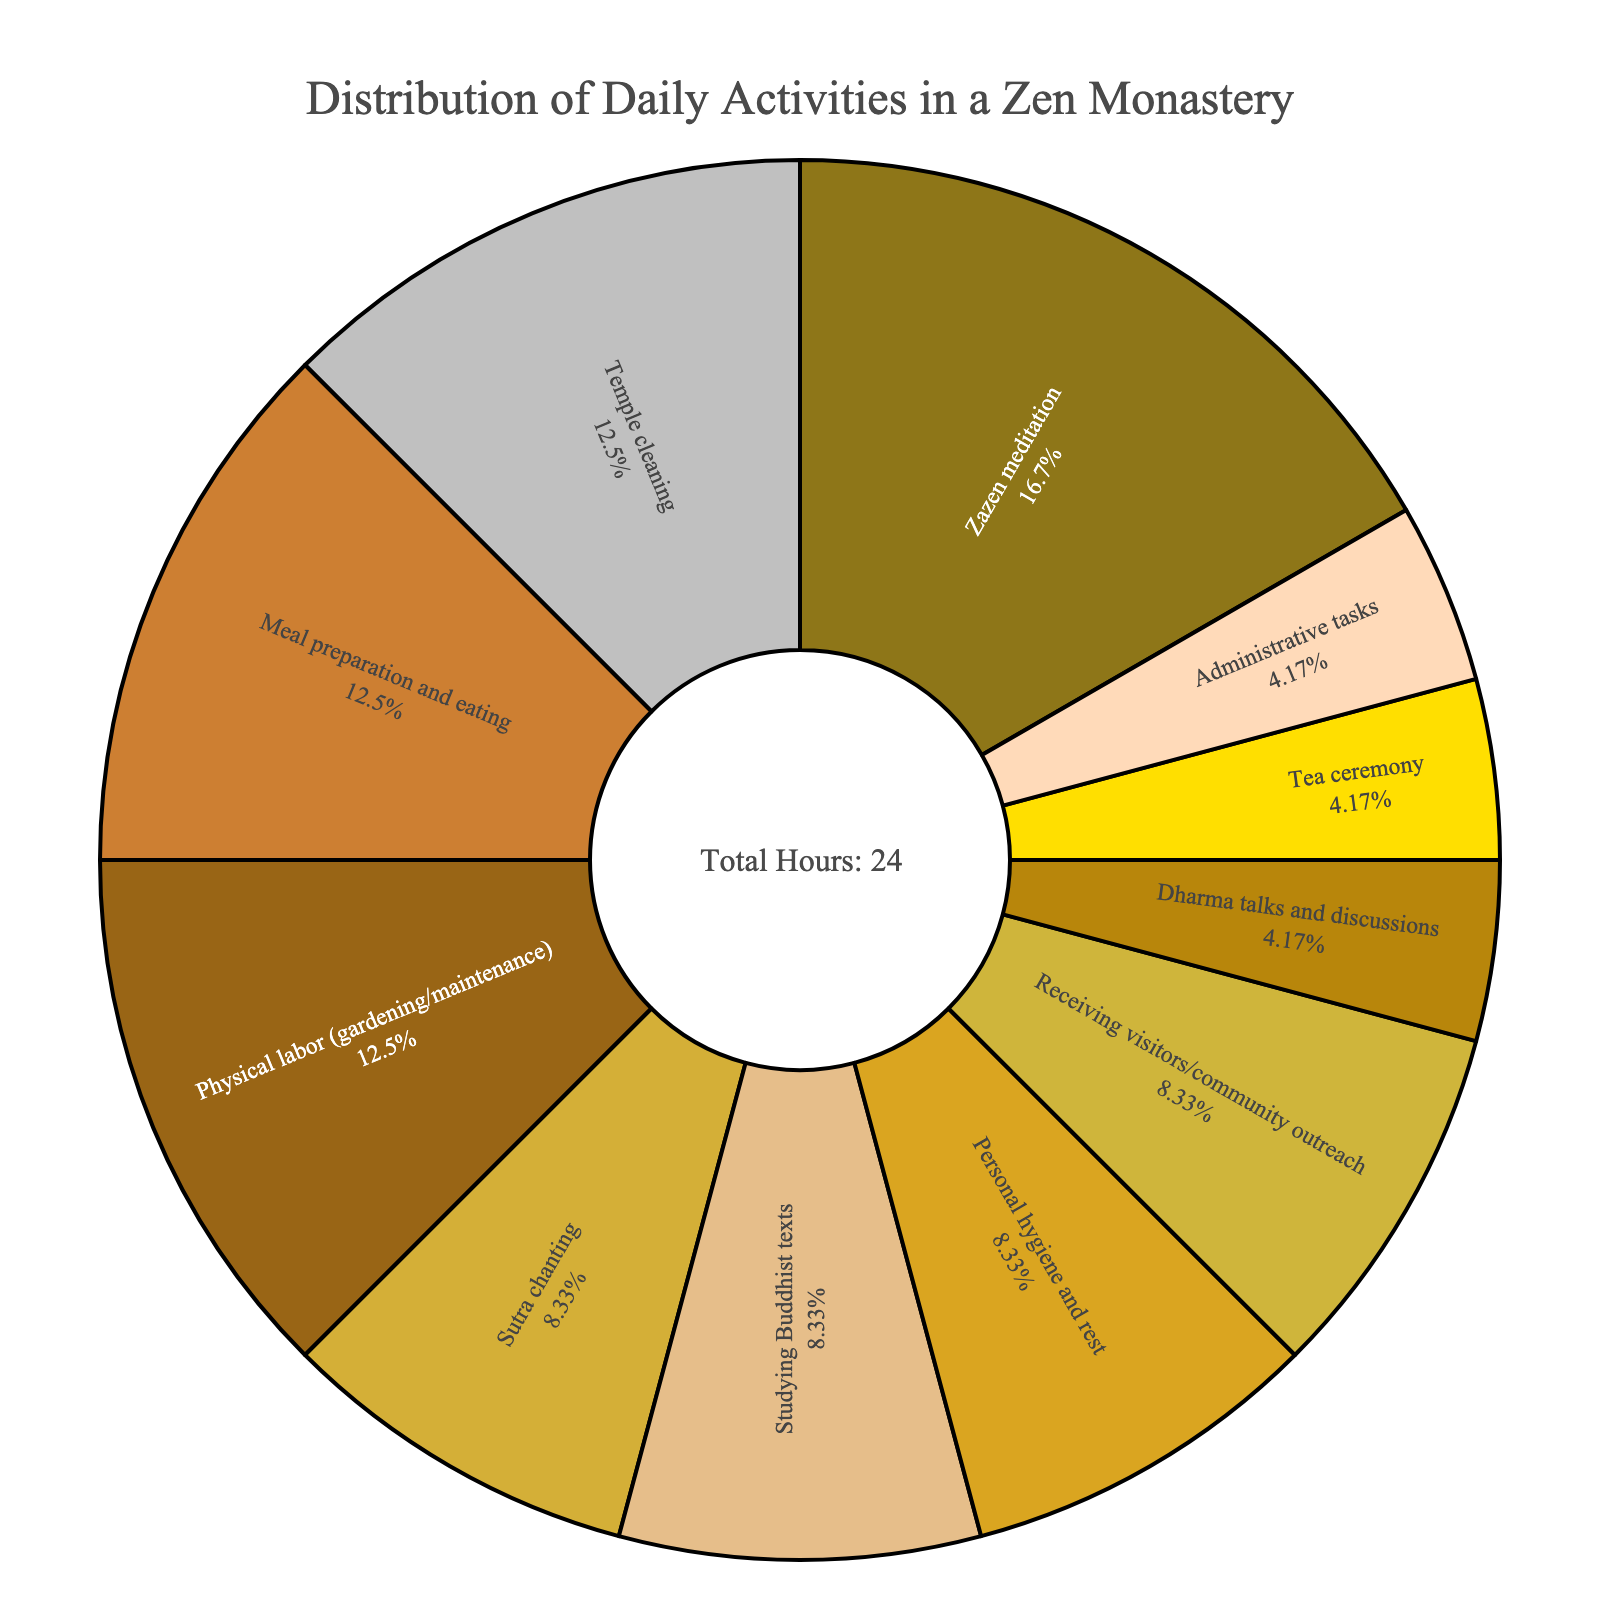What's the largest portion of daily activities? The largest portion can be identified by looking at the segment with the highest percentage. Zazen meditation, at 4 hours out of 24, takes up the largest portion of the daily activities.
Answer: Zazen meditation How many hours are spent on Temple cleaning and Meal preparation and eating combined? To find the total time spent on Temple cleaning and Meal preparation and eating, add the hours spent on each activity: 3 hours for Temple cleaning + 3 hours for Meal preparation and eating = 6 hours.
Answer: 6 hours Which activity accounts for more daily hours, Sutra chanting or Personal hygiene and rest? Comparing the segments of Sutra chanting and Personal hygiene and rest, Sutra chanting accounts for 2 hours while Personal hygiene and rest also accounts for 2 hours, so they are equal.
Answer: Equal What percentage of the day is spent on Studying Buddhist texts? The pie chart segment for Studying Buddhist texts represents its percentage of the total 24 hours. It is 2 hours out of 24, which is (2/24) * 100 = 8.33%.
Answer: 8.33% Are there more hours spent on Physical labor or Dharma talks and discussions? By observing the chart, Physical labor amounts to 3 hours whereas Dharma talks and discussions amount to 1 hour. Hence, more hours are spent on Physical labor.
Answer: Physical labor What's the combined percentage of the day spent on Personal hygiene and rest and Tea ceremony? First, find the hours spent on each: Personal hygiene and rest (2 hours) + Tea ceremony (1 hour) = 3 hours. Then, calculate the percentage: (3/24) * 100 = 12.5%.
Answer: 12.5% How does Meal preparation and eating compare to Administrative tasks in terms of hours? Meal preparation and eating occupies 3 hours whereas Administrative tasks take 1 hour. Thus, Meal preparation and eating involves more hours.
Answer: Meal preparation and eating Which activities are equally distributed time-wise? The segments to look for are those with the same hours. Sutra chanting, Studying Buddhist texts, Personal hygiene and rest, and Receiving visitors/community outreach all occupy 2 hours each.
Answer: Sutra chanting, Studying Buddhist texts, Personal hygiene and rest, Receiving visitors/community outreach What is the visual indicator used to represent Zazen meditation? Observing the chart's color scheme, Zazen meditation is represented by a specific color (likely dark from the presented palette). Identify the color directly in the chart for the exact visual indicator.
Answer: Dark color (specific visual needed) How much more time is spent on Physical labor compared to Administrative tasks? To determine this, calculate the difference: 3 hours for Physical labor - 1 hour for Administrative tasks = 2 hours more spent on Physical labor.
Answer: 2 hours 